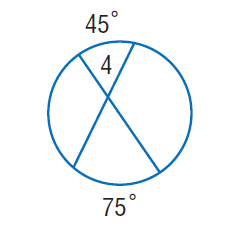Answer the mathemtical geometry problem and directly provide the correct option letter.
Question: Find \angle 4.
Choices: A: 45 B: 60 C: 75 D: 120 B 